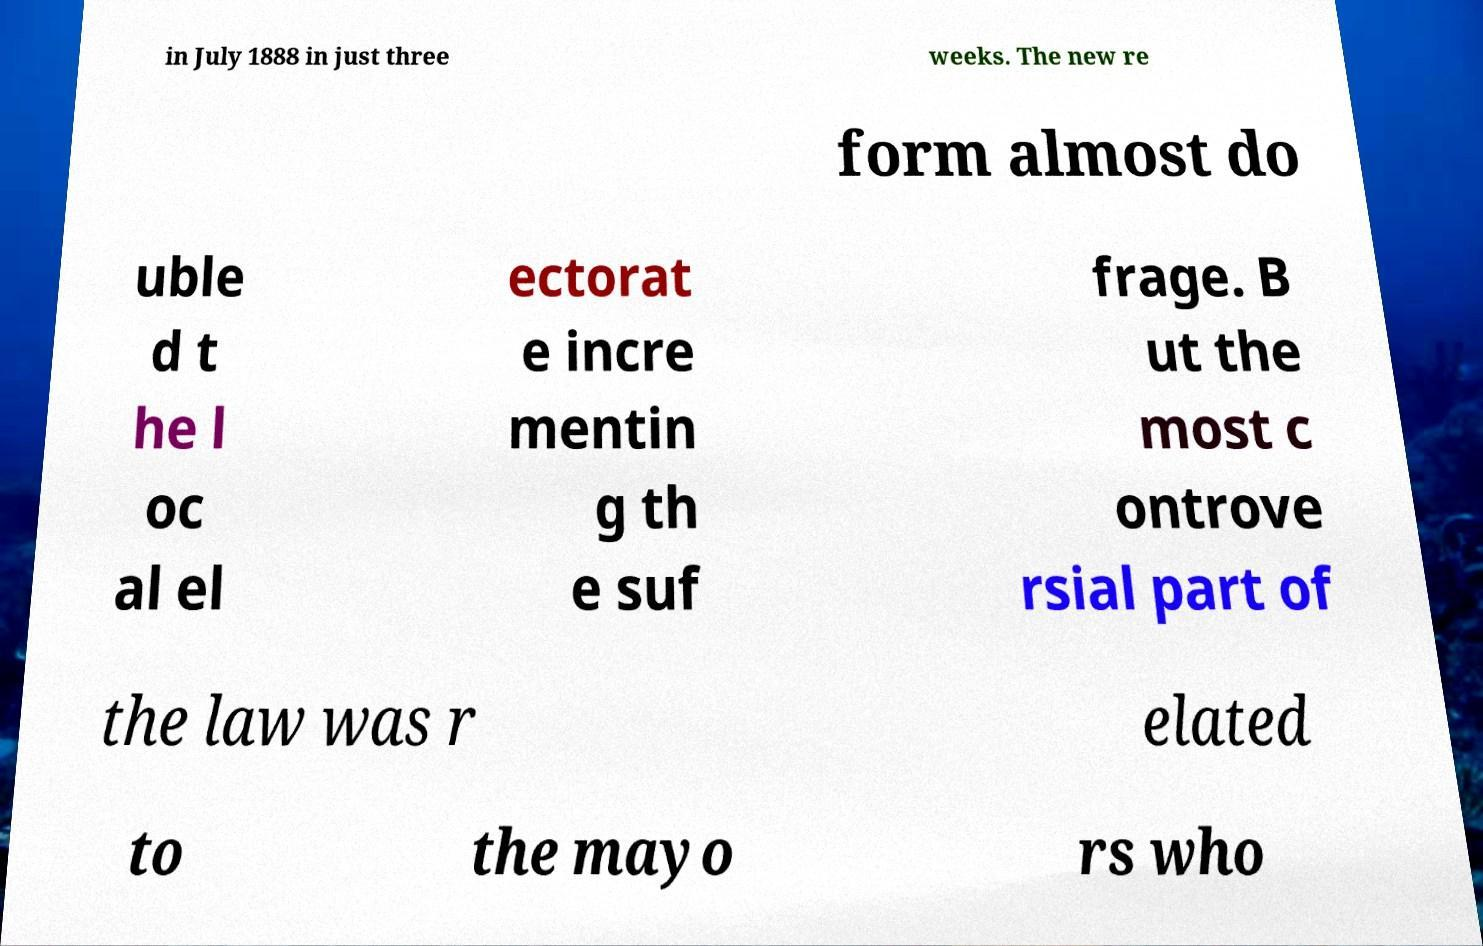There's text embedded in this image that I need extracted. Can you transcribe it verbatim? in July 1888 in just three weeks. The new re form almost do uble d t he l oc al el ectorat e incre mentin g th e suf frage. B ut the most c ontrove rsial part of the law was r elated to the mayo rs who 